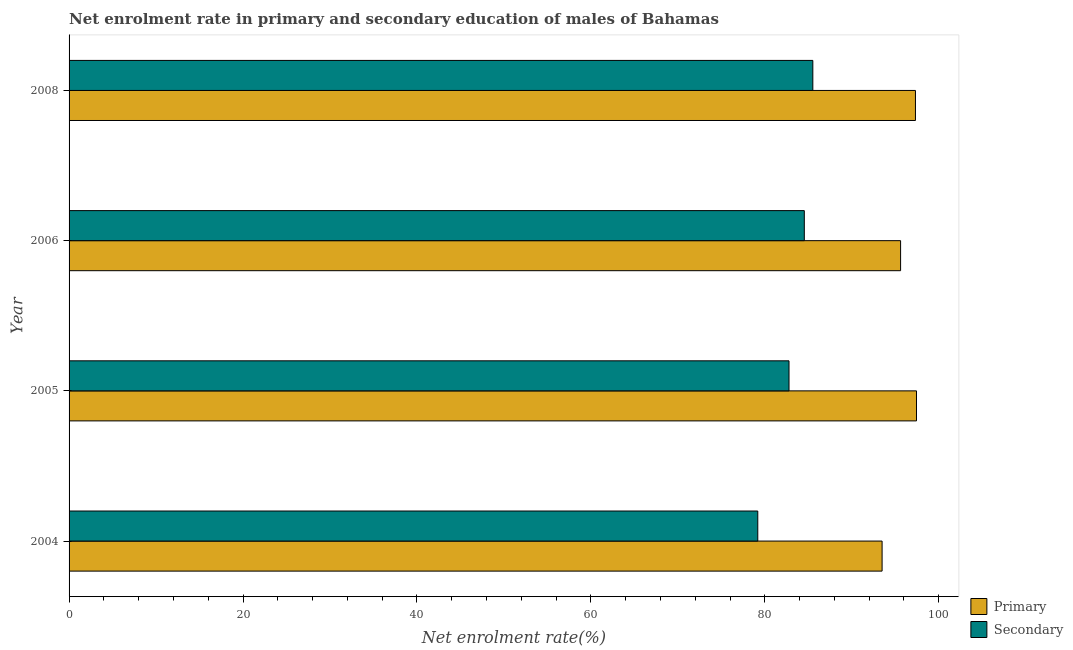How many groups of bars are there?
Your answer should be compact. 4. Are the number of bars on each tick of the Y-axis equal?
Provide a succinct answer. Yes. In how many cases, is the number of bars for a given year not equal to the number of legend labels?
Give a very brief answer. 0. What is the enrollment rate in primary education in 2008?
Your response must be concise. 97.32. Across all years, what is the maximum enrollment rate in primary education?
Provide a short and direct response. 97.44. Across all years, what is the minimum enrollment rate in primary education?
Provide a short and direct response. 93.49. In which year was the enrollment rate in primary education maximum?
Your answer should be compact. 2005. What is the total enrollment rate in primary education in the graph?
Provide a short and direct response. 383.87. What is the difference between the enrollment rate in primary education in 2006 and that in 2008?
Give a very brief answer. -1.71. What is the difference between the enrollment rate in primary education in 2006 and the enrollment rate in secondary education in 2008?
Ensure brevity in your answer.  10.09. What is the average enrollment rate in primary education per year?
Make the answer very short. 95.97. In the year 2004, what is the difference between the enrollment rate in secondary education and enrollment rate in primary education?
Ensure brevity in your answer.  -14.29. In how many years, is the enrollment rate in primary education greater than 44 %?
Ensure brevity in your answer.  4. What is the ratio of the enrollment rate in secondary education in 2006 to that in 2008?
Offer a terse response. 0.99. Is the enrollment rate in primary education in 2004 less than that in 2008?
Your answer should be compact. Yes. What is the difference between the highest and the second highest enrollment rate in primary education?
Give a very brief answer. 0.12. What is the difference between the highest and the lowest enrollment rate in primary education?
Your answer should be very brief. 3.96. Is the sum of the enrollment rate in secondary education in 2004 and 2006 greater than the maximum enrollment rate in primary education across all years?
Give a very brief answer. Yes. What does the 2nd bar from the top in 2008 represents?
Your answer should be very brief. Primary. What does the 2nd bar from the bottom in 2006 represents?
Give a very brief answer. Secondary. Are all the bars in the graph horizontal?
Provide a short and direct response. Yes. How many years are there in the graph?
Provide a succinct answer. 4. What is the difference between two consecutive major ticks on the X-axis?
Keep it short and to the point. 20. Are the values on the major ticks of X-axis written in scientific E-notation?
Provide a short and direct response. No. Does the graph contain any zero values?
Your response must be concise. No. What is the title of the graph?
Provide a short and direct response. Net enrolment rate in primary and secondary education of males of Bahamas. Does "Largest city" appear as one of the legend labels in the graph?
Keep it short and to the point. No. What is the label or title of the X-axis?
Your answer should be very brief. Net enrolment rate(%). What is the Net enrolment rate(%) in Primary in 2004?
Ensure brevity in your answer.  93.49. What is the Net enrolment rate(%) in Secondary in 2004?
Your response must be concise. 79.19. What is the Net enrolment rate(%) in Primary in 2005?
Ensure brevity in your answer.  97.44. What is the Net enrolment rate(%) in Secondary in 2005?
Ensure brevity in your answer.  82.78. What is the Net enrolment rate(%) in Primary in 2006?
Your answer should be compact. 95.61. What is the Net enrolment rate(%) in Secondary in 2006?
Provide a succinct answer. 84.54. What is the Net enrolment rate(%) of Primary in 2008?
Offer a terse response. 97.32. What is the Net enrolment rate(%) of Secondary in 2008?
Make the answer very short. 85.52. Across all years, what is the maximum Net enrolment rate(%) of Primary?
Give a very brief answer. 97.44. Across all years, what is the maximum Net enrolment rate(%) in Secondary?
Offer a very short reply. 85.52. Across all years, what is the minimum Net enrolment rate(%) of Primary?
Your answer should be compact. 93.49. Across all years, what is the minimum Net enrolment rate(%) in Secondary?
Provide a short and direct response. 79.19. What is the total Net enrolment rate(%) of Primary in the graph?
Provide a short and direct response. 383.87. What is the total Net enrolment rate(%) in Secondary in the graph?
Your answer should be compact. 332.04. What is the difference between the Net enrolment rate(%) in Primary in 2004 and that in 2005?
Provide a short and direct response. -3.96. What is the difference between the Net enrolment rate(%) of Secondary in 2004 and that in 2005?
Give a very brief answer. -3.59. What is the difference between the Net enrolment rate(%) in Primary in 2004 and that in 2006?
Offer a very short reply. -2.13. What is the difference between the Net enrolment rate(%) in Secondary in 2004 and that in 2006?
Your answer should be compact. -5.35. What is the difference between the Net enrolment rate(%) in Primary in 2004 and that in 2008?
Keep it short and to the point. -3.84. What is the difference between the Net enrolment rate(%) of Secondary in 2004 and that in 2008?
Provide a succinct answer. -6.33. What is the difference between the Net enrolment rate(%) in Primary in 2005 and that in 2006?
Provide a succinct answer. 1.83. What is the difference between the Net enrolment rate(%) in Secondary in 2005 and that in 2006?
Your answer should be very brief. -1.76. What is the difference between the Net enrolment rate(%) in Primary in 2005 and that in 2008?
Ensure brevity in your answer.  0.12. What is the difference between the Net enrolment rate(%) of Secondary in 2005 and that in 2008?
Your answer should be very brief. -2.74. What is the difference between the Net enrolment rate(%) in Primary in 2006 and that in 2008?
Give a very brief answer. -1.71. What is the difference between the Net enrolment rate(%) of Secondary in 2006 and that in 2008?
Offer a very short reply. -0.98. What is the difference between the Net enrolment rate(%) of Primary in 2004 and the Net enrolment rate(%) of Secondary in 2005?
Your answer should be very brief. 10.7. What is the difference between the Net enrolment rate(%) of Primary in 2004 and the Net enrolment rate(%) of Secondary in 2006?
Give a very brief answer. 8.94. What is the difference between the Net enrolment rate(%) of Primary in 2004 and the Net enrolment rate(%) of Secondary in 2008?
Provide a short and direct response. 7.96. What is the difference between the Net enrolment rate(%) in Primary in 2005 and the Net enrolment rate(%) in Secondary in 2006?
Your answer should be very brief. 12.9. What is the difference between the Net enrolment rate(%) in Primary in 2005 and the Net enrolment rate(%) in Secondary in 2008?
Offer a very short reply. 11.92. What is the difference between the Net enrolment rate(%) in Primary in 2006 and the Net enrolment rate(%) in Secondary in 2008?
Your answer should be very brief. 10.09. What is the average Net enrolment rate(%) in Primary per year?
Offer a very short reply. 95.97. What is the average Net enrolment rate(%) in Secondary per year?
Your response must be concise. 83.01. In the year 2004, what is the difference between the Net enrolment rate(%) in Primary and Net enrolment rate(%) in Secondary?
Ensure brevity in your answer.  14.29. In the year 2005, what is the difference between the Net enrolment rate(%) of Primary and Net enrolment rate(%) of Secondary?
Offer a terse response. 14.66. In the year 2006, what is the difference between the Net enrolment rate(%) in Primary and Net enrolment rate(%) in Secondary?
Your response must be concise. 11.07. In the year 2008, what is the difference between the Net enrolment rate(%) of Primary and Net enrolment rate(%) of Secondary?
Provide a short and direct response. 11.8. What is the ratio of the Net enrolment rate(%) of Primary in 2004 to that in 2005?
Your response must be concise. 0.96. What is the ratio of the Net enrolment rate(%) of Secondary in 2004 to that in 2005?
Your answer should be compact. 0.96. What is the ratio of the Net enrolment rate(%) in Primary in 2004 to that in 2006?
Give a very brief answer. 0.98. What is the ratio of the Net enrolment rate(%) of Secondary in 2004 to that in 2006?
Offer a terse response. 0.94. What is the ratio of the Net enrolment rate(%) of Primary in 2004 to that in 2008?
Provide a short and direct response. 0.96. What is the ratio of the Net enrolment rate(%) of Secondary in 2004 to that in 2008?
Make the answer very short. 0.93. What is the ratio of the Net enrolment rate(%) in Primary in 2005 to that in 2006?
Keep it short and to the point. 1.02. What is the ratio of the Net enrolment rate(%) in Secondary in 2005 to that in 2006?
Provide a short and direct response. 0.98. What is the ratio of the Net enrolment rate(%) in Primary in 2005 to that in 2008?
Provide a succinct answer. 1. What is the ratio of the Net enrolment rate(%) in Primary in 2006 to that in 2008?
Your response must be concise. 0.98. What is the difference between the highest and the second highest Net enrolment rate(%) of Primary?
Provide a short and direct response. 0.12. What is the difference between the highest and the second highest Net enrolment rate(%) in Secondary?
Provide a succinct answer. 0.98. What is the difference between the highest and the lowest Net enrolment rate(%) of Primary?
Offer a very short reply. 3.96. What is the difference between the highest and the lowest Net enrolment rate(%) of Secondary?
Make the answer very short. 6.33. 